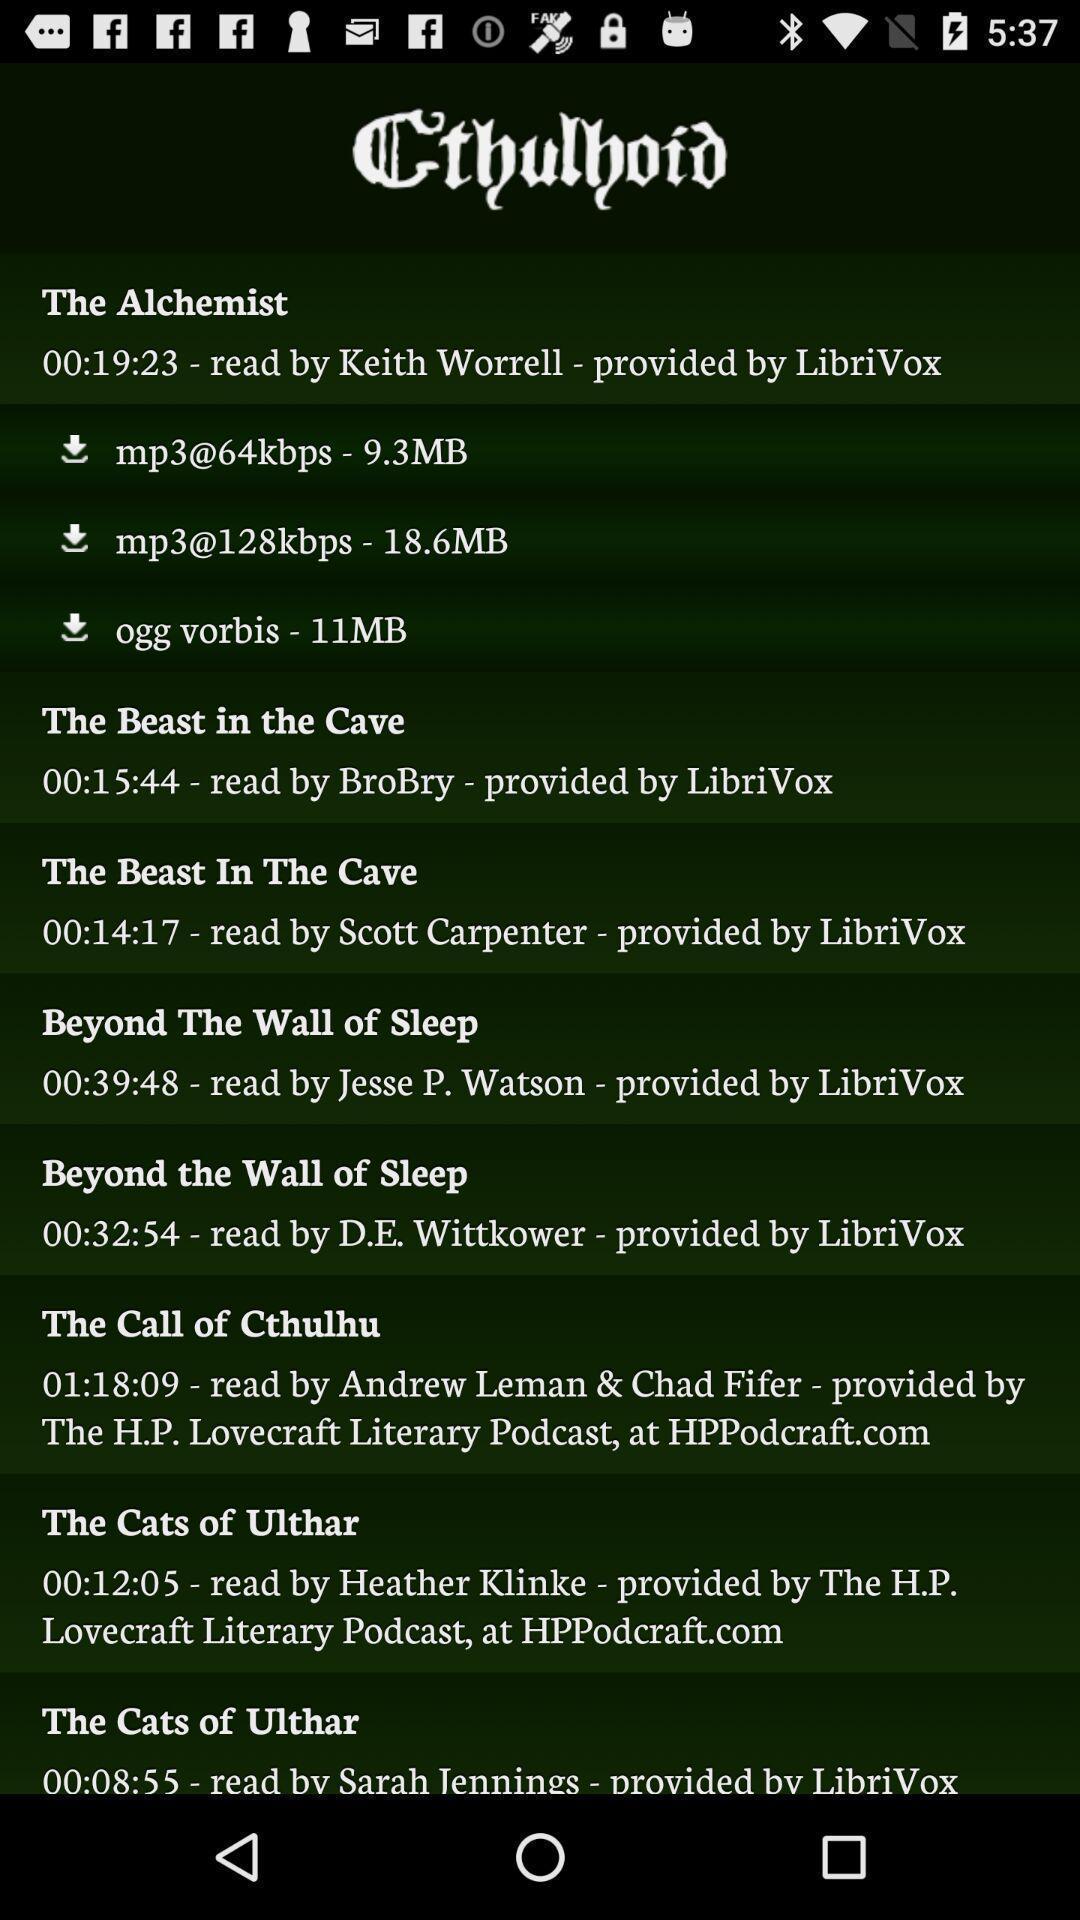Tell me about the visual elements in this screen capture. Page showing the various list of stories. 